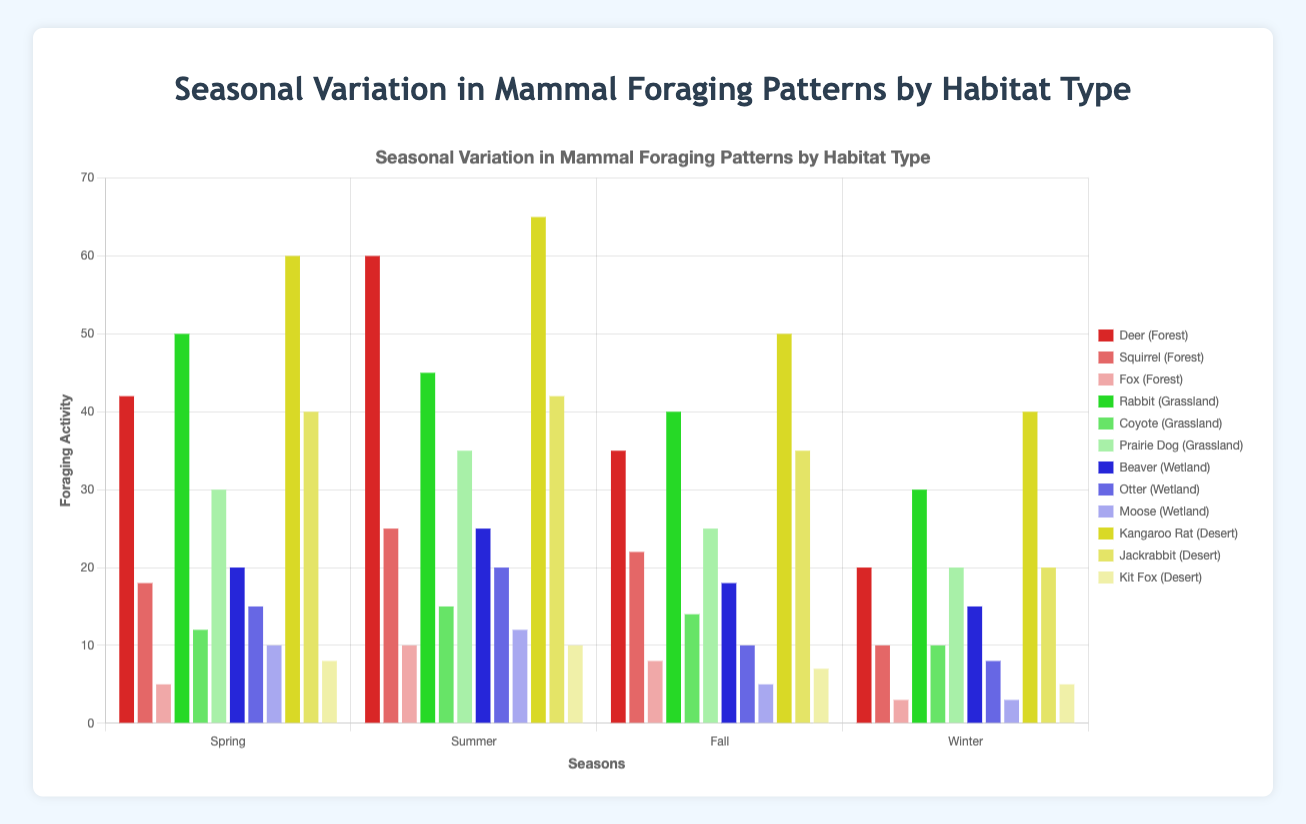What is the total foraging activity of Deer across all seasons in the Forest habitat? To find the total foraging activity of Deer in the Forest habitat, we need to sum the values for all seasons: 42 (Spring) + 60 (Summer) + 35 (Fall) + 20 (Winter) = 157.
Answer: 157 Which habitat type shows the highest foraging activity for Squirrels in the Summer? To determine the habitat type with the highest foraging activity for Squirrels in the Summer, compare the activity values for the four habitat types during the Summer season. Squirrels are only active in the Forest habitat during Summer with an activity value of 25.
Answer: Forest How does the foraging activity of Foxes in the Winter compare between the Forest and Desert habitats? Compare the Winter activity values for Foxes in both habitats: Forest (3) and Desert (5). The Desert habitat has a higher activity for Foxes in Winter.
Answer: Desert What is the average foraging activity of Rabbits in the Grassland habitat across all seasons? To find the average foraging activity, sum the values for all seasons and divide by the number of seasons: (50 + 45 + 40 + 30) / 4 = 165 / 4 = 41.25.
Answer: 41.25 Which season has the lowest foraging activity for Beavers in the Wetland habitat? Compare the foraging activities for Beavers in the Wetland habitat across all seasons: Spring (20), Summer (25), Fall (18), and Winter (15). The lowest activity occurs in Winter.
Answer: Winter Which animal has the highest foraging activity in the Spring in the Desert habitat? Compare the foraging activity values for animals in the Spring in the Desert habitat: Kangaroo Rat (60), Jackrabbit (40), and Kit Fox (8). Kangaroo Rat has the highest activity.
Answer: Kangaroo Rat What is the combined foraging activity of Prairie Dogs and Coyotes in the Summer in the Grassland habitat? To find the combined activity, sum the values for both animals in that season: Prairie Dog (35) + Coyote (15) = 50.
Answer: 50 How much does the foraging activity of Jackrabbits in the Desert habitat decrease from Summer to Winter? Calculate the difference in foraging activity for Jackrabbits from Summer to Winter: 42 (Summer) - 20 (Winter) = 22.
Answer: 22 Which combination of habitat type and season shows the highest foraging activity for any animal? Compare the highest values of foraging activity across all combinations. The highest value is Kangaroo Rat in Desert during Summer (65).
Answer: Desert in Summer What visual attribute distinguishes Kangaroo Rat's activity in the Winter across different habitats? The visual attribute that distinguishes Kangaroo Rat's activity in Winter is the height of the bars. The bar for the Desert habitat is higher than any other usage values in other habitats.
Answer: bar height 